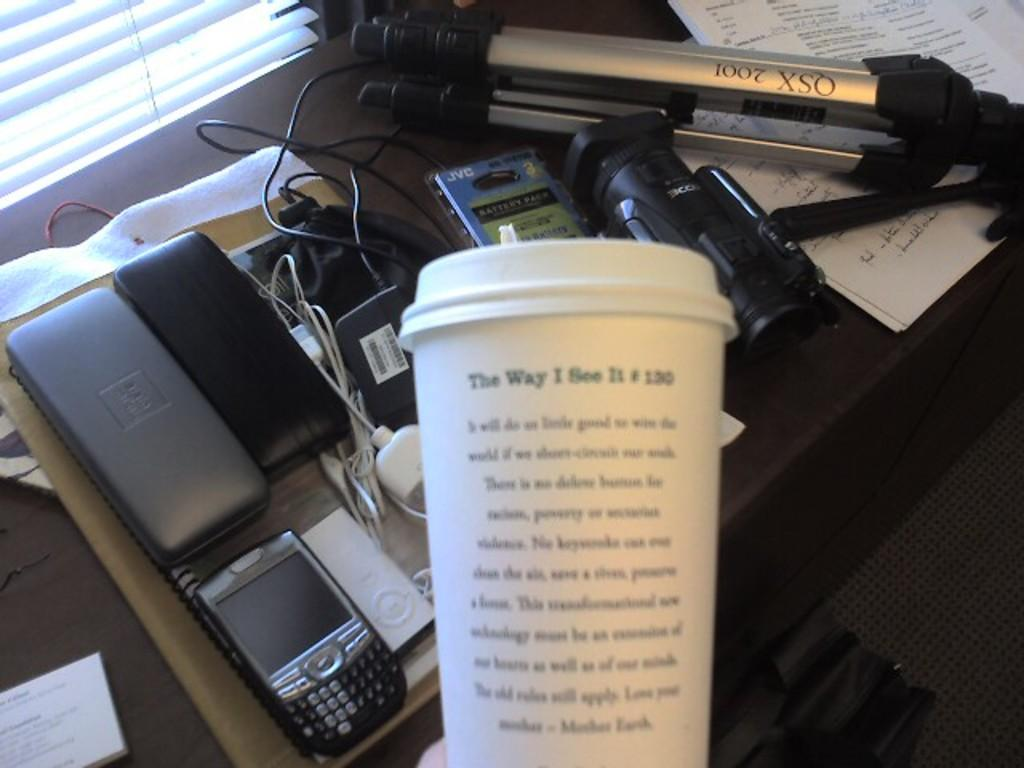<image>
Present a compact description of the photo's key features. A disposal coffee cup that says The Way I see It #130 on it. 